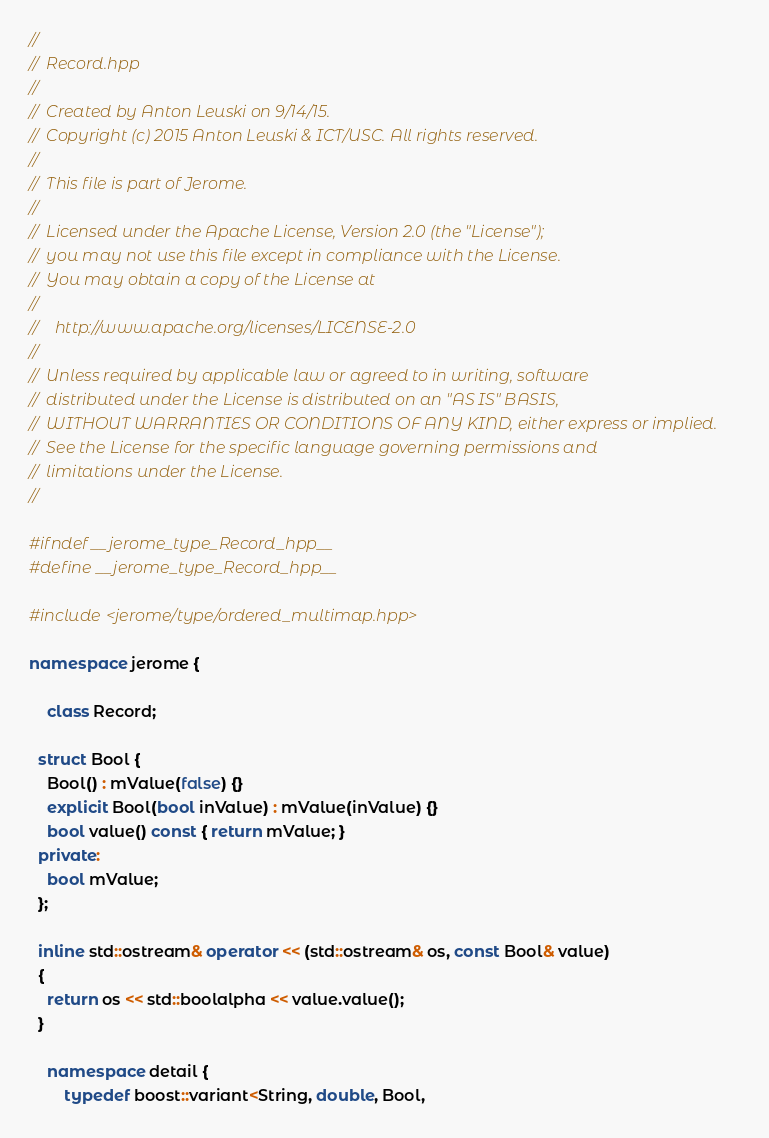<code> <loc_0><loc_0><loc_500><loc_500><_C++_>//
//  Record.hpp
//
//  Created by Anton Leuski on 9/14/15.
//  Copyright (c) 2015 Anton Leuski & ICT/USC. All rights reserved.
//
//  This file is part of Jerome.
//
//  Licensed under the Apache License, Version 2.0 (the "License");
//  you may not use this file except in compliance with the License.
//  You may obtain a copy of the License at
//
//    http://www.apache.org/licenses/LICENSE-2.0
//
//  Unless required by applicable law or agreed to in writing, software
//  distributed under the License is distributed on an "AS IS" BASIS,
//  WITHOUT WARRANTIES OR CONDITIONS OF ANY KIND, either express or implied.
//  See the License for the specific language governing permissions and
//  limitations under the License.
//

#ifndef __jerome_type_Record_hpp__
#define __jerome_type_Record_hpp__

#include <jerome/type/ordered_multimap.hpp>

namespace jerome {
	
	class Record;
  
  struct Bool {
    Bool() : mValue(false) {}
    explicit Bool(bool inValue) : mValue(inValue) {}
    bool value() const { return mValue; }
  private:
    bool mValue;
  };
  
  inline std::ostream& operator << (std::ostream& os, const Bool& value)
  {
    return os << std::boolalpha << value.value();
  }
	
	namespace detail {
		typedef boost::variant<String, double, Bool,</code> 